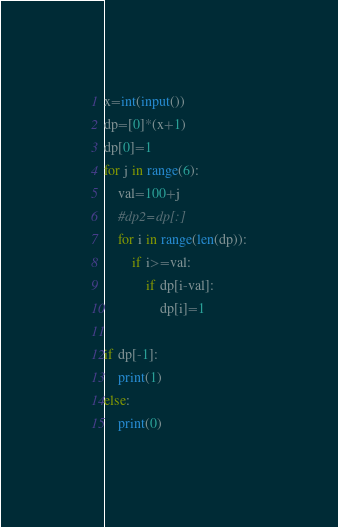<code> <loc_0><loc_0><loc_500><loc_500><_Python_>x=int(input())
dp=[0]*(x+1)
dp[0]=1
for j in range(6):
    val=100+j
    #dp2=dp[:]
    for i in range(len(dp)):
        if i>=val:
            if dp[i-val]:
                dp[i]=1

if dp[-1]:
    print(1)
else:
    print(0)
</code> 